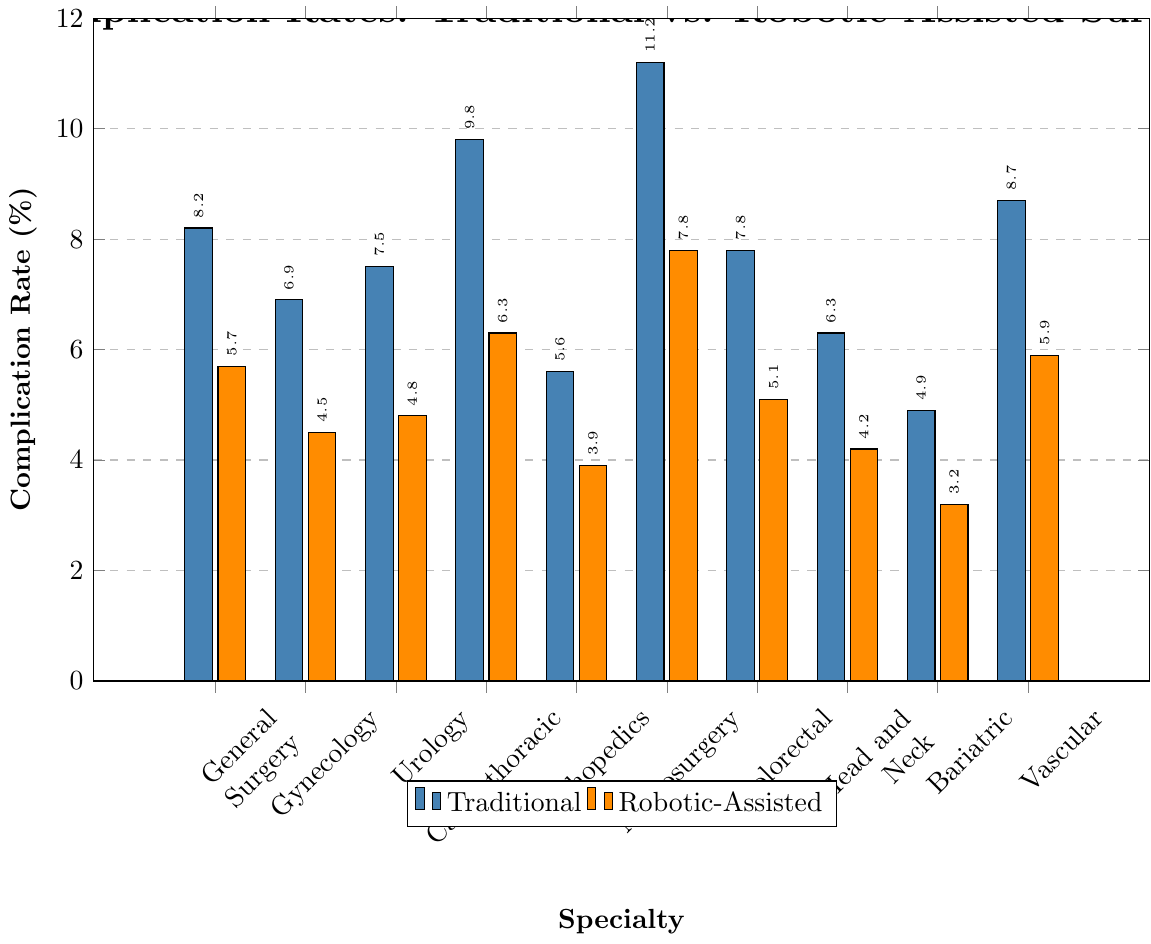What's the specialty with the highest traditional complication rate? Looking at the tallest bar in the set of traditional complication rates, Neurosurgery has the highest rate at 11.2%.
Answer: Neurosurgery Which specialty shows the greatest reduction in complication rates when using robotic-assisted surgery compared to traditional surgery? Calculate the difference between traditional and robotic-assisted rates for each specialty. Neurosurgery shows the greatest reduction from 11.2% to 7.8%, which is a reduction of 3.4%.
Answer: Neurosurgery What's the average traditional complication rate across all specialties? Sum up the traditional complication rates and then divide by the number of specialties. Sum = 8.2 + 6.9 + 7.5 + 9.8 + 5.6 + 11.2 + 7.8 + 6.3 + 4.9 + 8.7 = 76.9. Number of specialties = 10. Average = 76.9 / 10 = 7.69%.
Answer: 7.69% What's the total complication rate difference for Cardiothoracic Surgery when comparing traditional and robotic-assisted methods? Subtract the robotic-assisted rate from the traditional rate for Cardiothoracic Surgery: 9.8% - 6.3% = 3.5%.
Answer: 3.5% How much lower is the complication rate for Orthopedics when using robotic-assisted surgery compared to traditional surgery? Subtract the robotic-assisted rate from the traditional rate for Orthopedics: 5.6% - 3.9% = 1.7%.
Answer: 1.7% Which specialty shows the smallest difference between traditional and robotic-assisted complication rates? Find the difference between traditional and robotic-assisted rates for each specialty and identify the smallest difference. Urology shows the smallest difference of 2.7% (7.5% - 4.8%).
Answer: Urology Is there any specialty where the robotic-assisted complication rate exceeds 6%? Looking at the bars for robotic-assisted surgeries, no specialty shows a complication rate exceeding 6%. The highest robotic-assisted rate is for Neurosurgery at 7.8%.
Answer: No Among the listed specialties, which one benefits the most from robotic-assisted surgery in terms of reduced complication rates? Compare the reductions in complication rates for all specialties. Neurosurgery benefits the most with a reduction of 3.4%.
Answer: Neurosurgery What is the visual trend observed between traditional and robotic-assisted complication rates across specialties? Observing the figure, robotic-assisted complication rates are consistently lower than traditional complication rates across all specialties.
Answer: Robotic-assisted rates are lower 